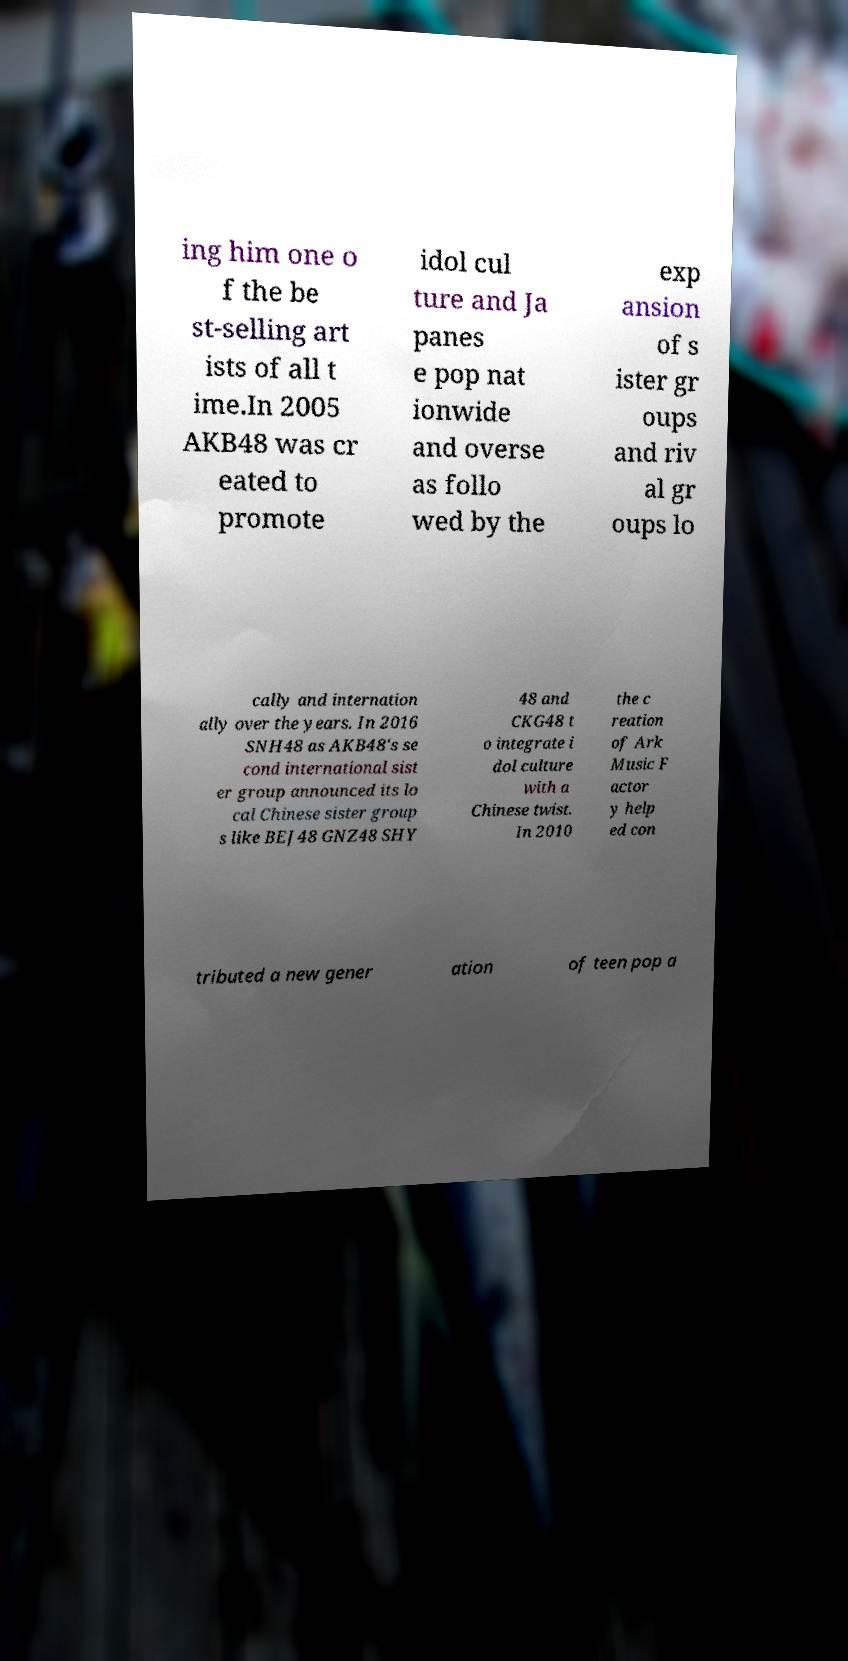Can you read and provide the text displayed in the image?This photo seems to have some interesting text. Can you extract and type it out for me? ing him one o f the be st-selling art ists of all t ime.In 2005 AKB48 was cr eated to promote idol cul ture and Ja panes e pop nat ionwide and overse as follo wed by the exp ansion of s ister gr oups and riv al gr oups lo cally and internation ally over the years. In 2016 SNH48 as AKB48's se cond international sist er group announced its lo cal Chinese sister group s like BEJ48 GNZ48 SHY 48 and CKG48 t o integrate i dol culture with a Chinese twist. In 2010 the c reation of Ark Music F actor y help ed con tributed a new gener ation of teen pop a 